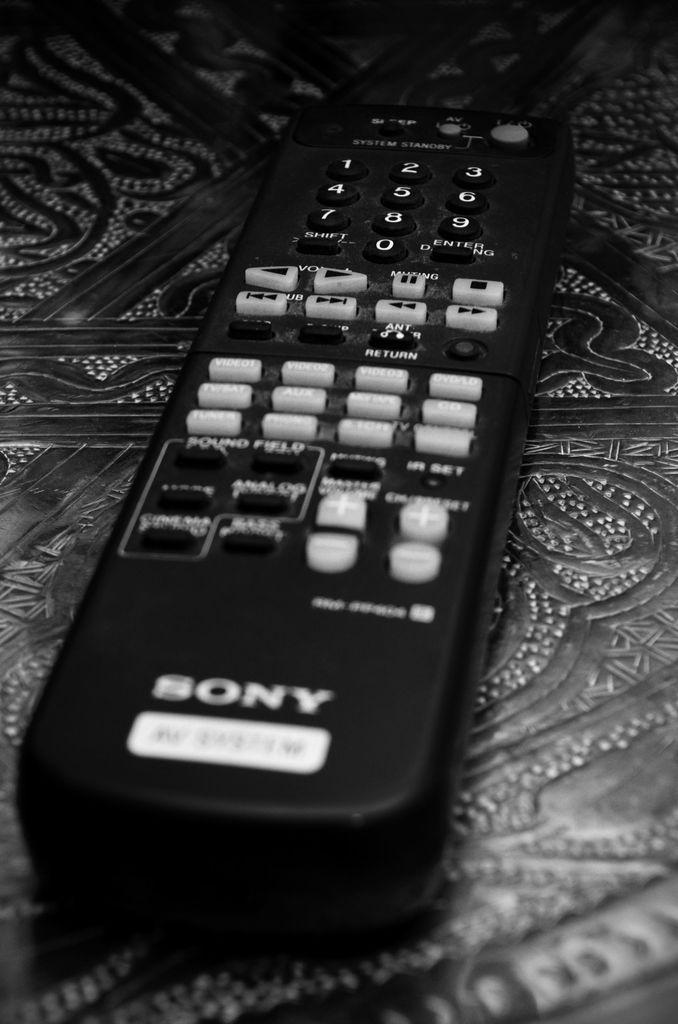<image>
Create a compact narrative representing the image presented. A close up of a black Sony remote control. 